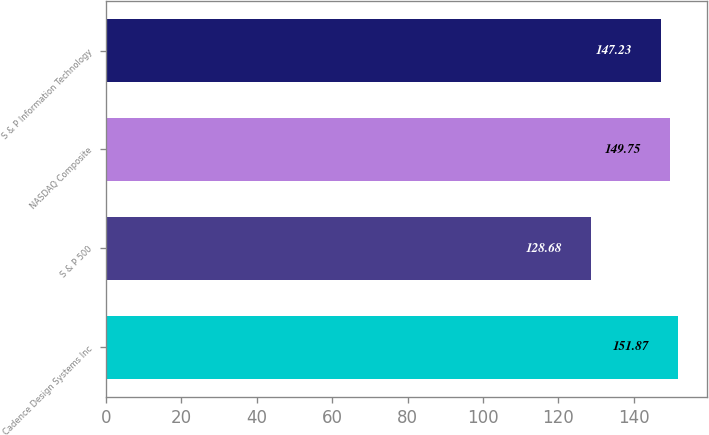Convert chart to OTSL. <chart><loc_0><loc_0><loc_500><loc_500><bar_chart><fcel>Cadence Design Systems Inc<fcel>S & P 500<fcel>NASDAQ Composite<fcel>S & P Information Technology<nl><fcel>151.87<fcel>128.68<fcel>149.75<fcel>147.23<nl></chart> 